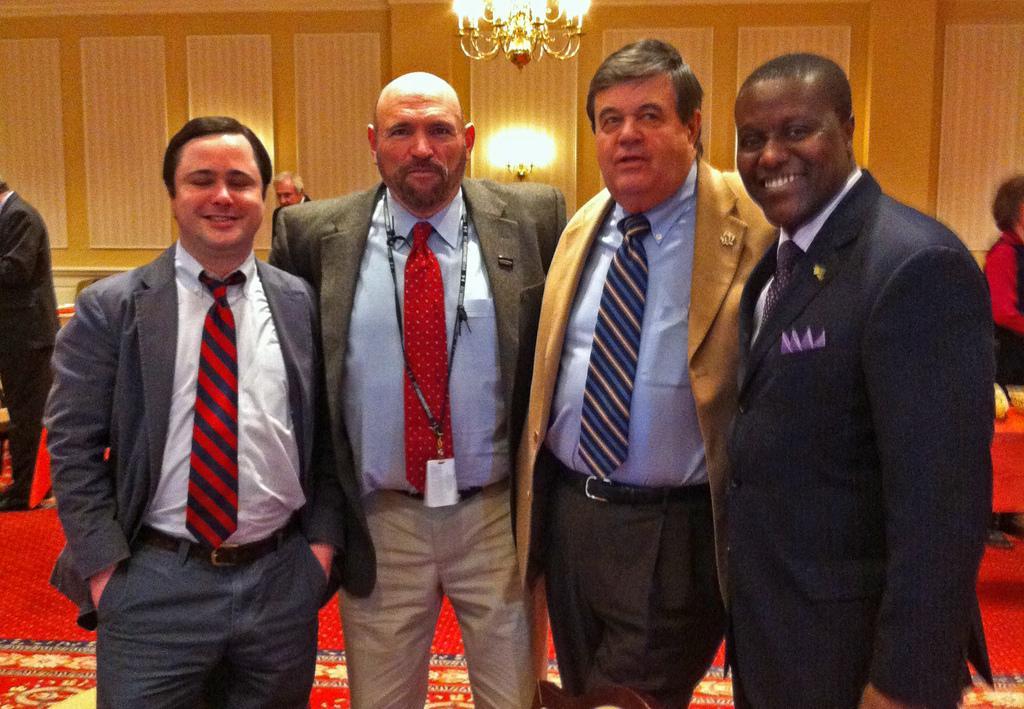Describe this image in one or two sentences. In this picture I can see few people are standing, behind we can see few people and also we can see some lights. 